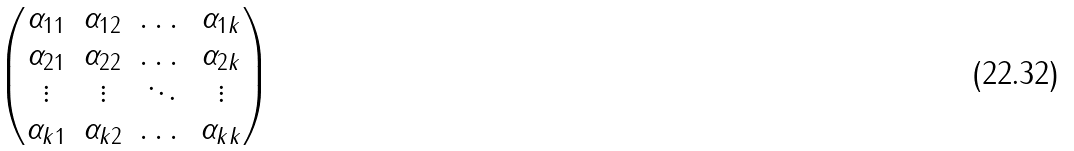Convert formula to latex. <formula><loc_0><loc_0><loc_500><loc_500>\begin{pmatrix} \alpha _ { 1 1 } & \alpha _ { 1 2 } & \dots & \alpha _ { 1 k } \\ \alpha _ { 2 1 } & \alpha _ { 2 2 } & \dots & \alpha _ { 2 k } \\ \vdots & \vdots & \ddots & \vdots \\ \alpha _ { k 1 } & \alpha _ { k 2 } & \dots & \alpha _ { k k } \\ \end{pmatrix}</formula> 